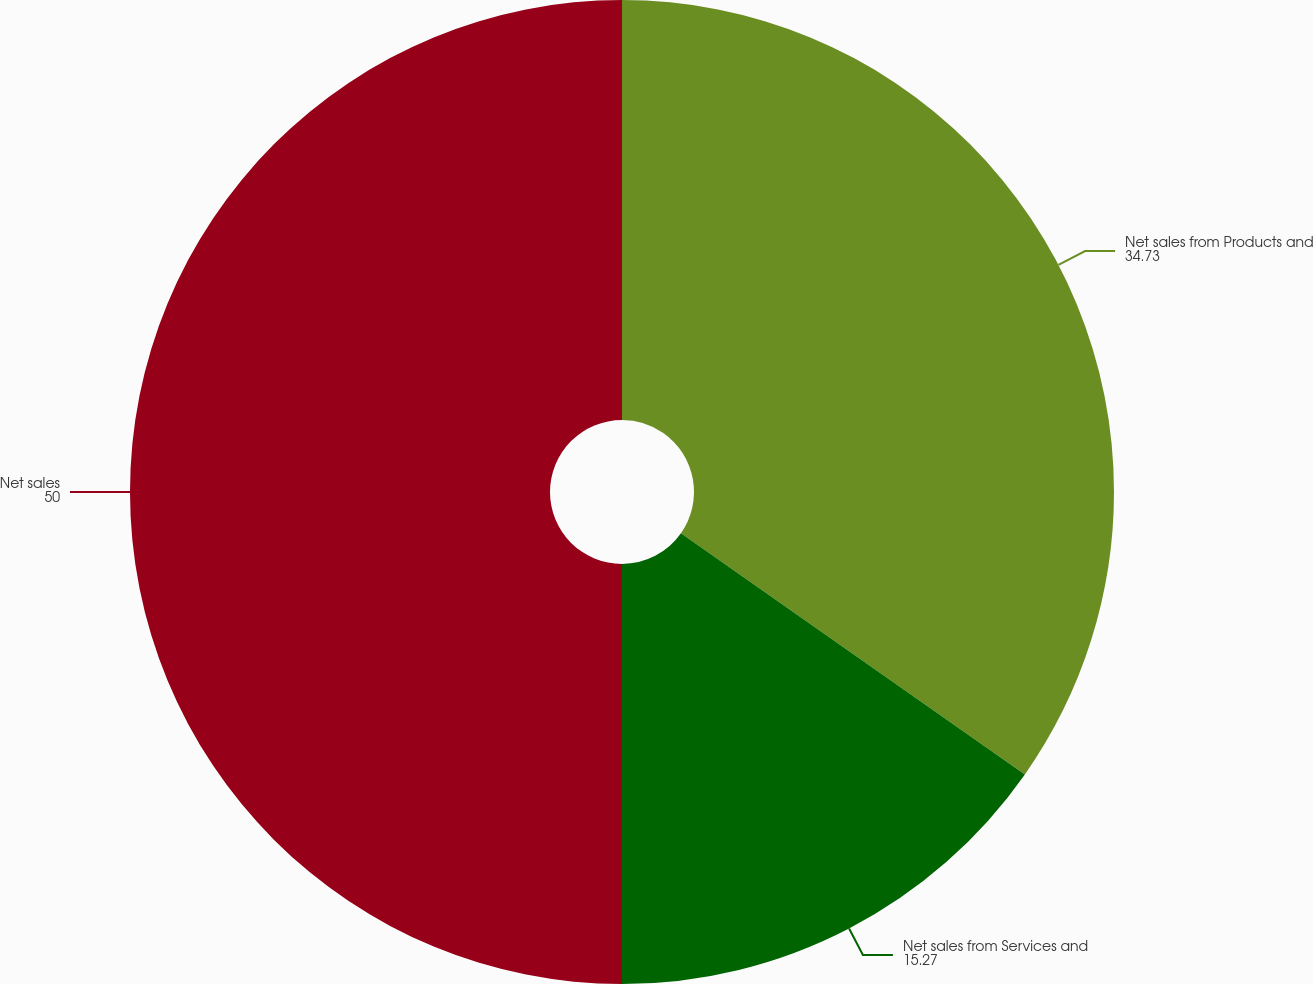<chart> <loc_0><loc_0><loc_500><loc_500><pie_chart><fcel>Net sales from Products and<fcel>Net sales from Services and<fcel>Net sales<nl><fcel>34.73%<fcel>15.27%<fcel>50.0%<nl></chart> 